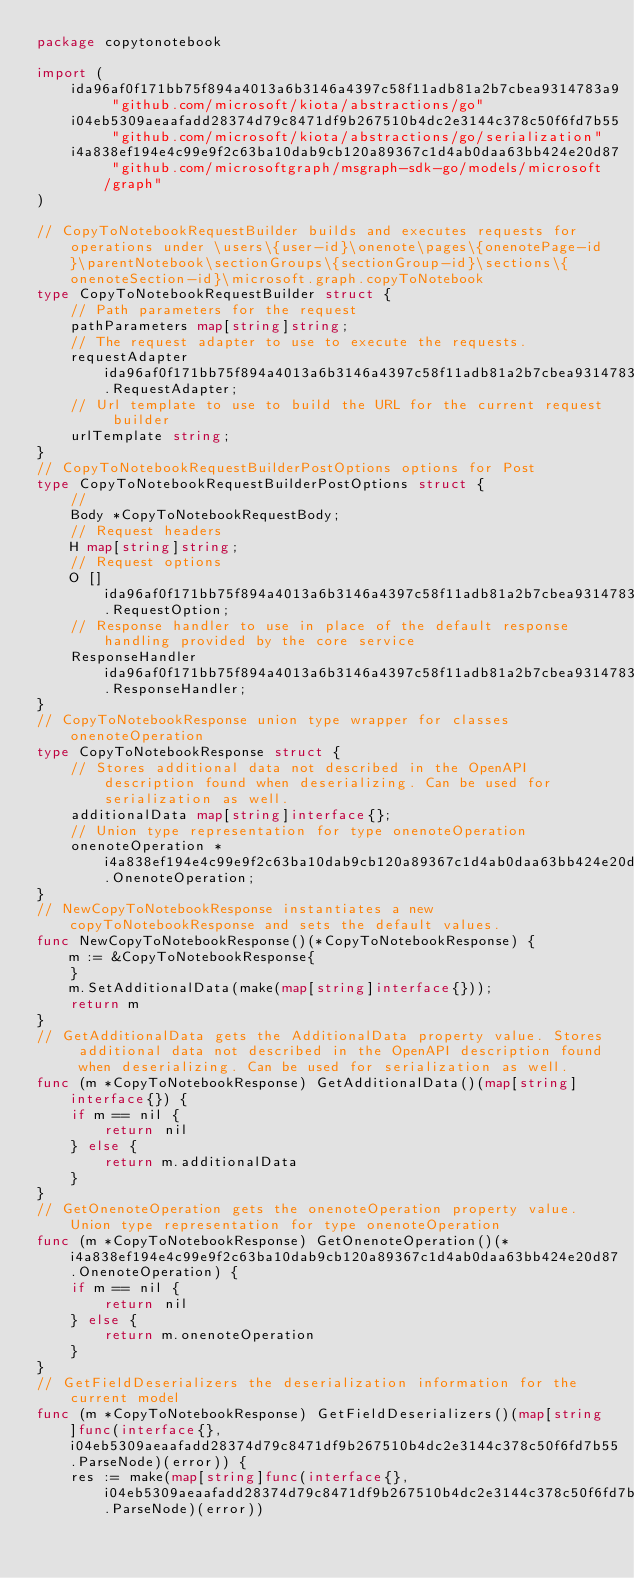<code> <loc_0><loc_0><loc_500><loc_500><_Go_>package copytonotebook

import (
    ida96af0f171bb75f894a4013a6b3146a4397c58f11adb81a2b7cbea9314783a9 "github.com/microsoft/kiota/abstractions/go"
    i04eb5309aeaafadd28374d79c8471df9b267510b4dc2e3144c378c50f6fd7b55 "github.com/microsoft/kiota/abstractions/go/serialization"
    i4a838ef194e4c99e9f2c63ba10dab9cb120a89367c1d4ab0daa63bb424e20d87 "github.com/microsoftgraph/msgraph-sdk-go/models/microsoft/graph"
)

// CopyToNotebookRequestBuilder builds and executes requests for operations under \users\{user-id}\onenote\pages\{onenotePage-id}\parentNotebook\sectionGroups\{sectionGroup-id}\sections\{onenoteSection-id}\microsoft.graph.copyToNotebook
type CopyToNotebookRequestBuilder struct {
    // Path parameters for the request
    pathParameters map[string]string;
    // The request adapter to use to execute the requests.
    requestAdapter ida96af0f171bb75f894a4013a6b3146a4397c58f11adb81a2b7cbea9314783a9.RequestAdapter;
    // Url template to use to build the URL for the current request builder
    urlTemplate string;
}
// CopyToNotebookRequestBuilderPostOptions options for Post
type CopyToNotebookRequestBuilderPostOptions struct {
    // 
    Body *CopyToNotebookRequestBody;
    // Request headers
    H map[string]string;
    // Request options
    O []ida96af0f171bb75f894a4013a6b3146a4397c58f11adb81a2b7cbea9314783a9.RequestOption;
    // Response handler to use in place of the default response handling provided by the core service
    ResponseHandler ida96af0f171bb75f894a4013a6b3146a4397c58f11adb81a2b7cbea9314783a9.ResponseHandler;
}
// CopyToNotebookResponse union type wrapper for classes onenoteOperation
type CopyToNotebookResponse struct {
    // Stores additional data not described in the OpenAPI description found when deserializing. Can be used for serialization as well.
    additionalData map[string]interface{};
    // Union type representation for type onenoteOperation
    onenoteOperation *i4a838ef194e4c99e9f2c63ba10dab9cb120a89367c1d4ab0daa63bb424e20d87.OnenoteOperation;
}
// NewCopyToNotebookResponse instantiates a new copyToNotebookResponse and sets the default values.
func NewCopyToNotebookResponse()(*CopyToNotebookResponse) {
    m := &CopyToNotebookResponse{
    }
    m.SetAdditionalData(make(map[string]interface{}));
    return m
}
// GetAdditionalData gets the AdditionalData property value. Stores additional data not described in the OpenAPI description found when deserializing. Can be used for serialization as well.
func (m *CopyToNotebookResponse) GetAdditionalData()(map[string]interface{}) {
    if m == nil {
        return nil
    } else {
        return m.additionalData
    }
}
// GetOnenoteOperation gets the onenoteOperation property value. Union type representation for type onenoteOperation
func (m *CopyToNotebookResponse) GetOnenoteOperation()(*i4a838ef194e4c99e9f2c63ba10dab9cb120a89367c1d4ab0daa63bb424e20d87.OnenoteOperation) {
    if m == nil {
        return nil
    } else {
        return m.onenoteOperation
    }
}
// GetFieldDeserializers the deserialization information for the current model
func (m *CopyToNotebookResponse) GetFieldDeserializers()(map[string]func(interface{}, i04eb5309aeaafadd28374d79c8471df9b267510b4dc2e3144c378c50f6fd7b55.ParseNode)(error)) {
    res := make(map[string]func(interface{}, i04eb5309aeaafadd28374d79c8471df9b267510b4dc2e3144c378c50f6fd7b55.ParseNode)(error))</code> 